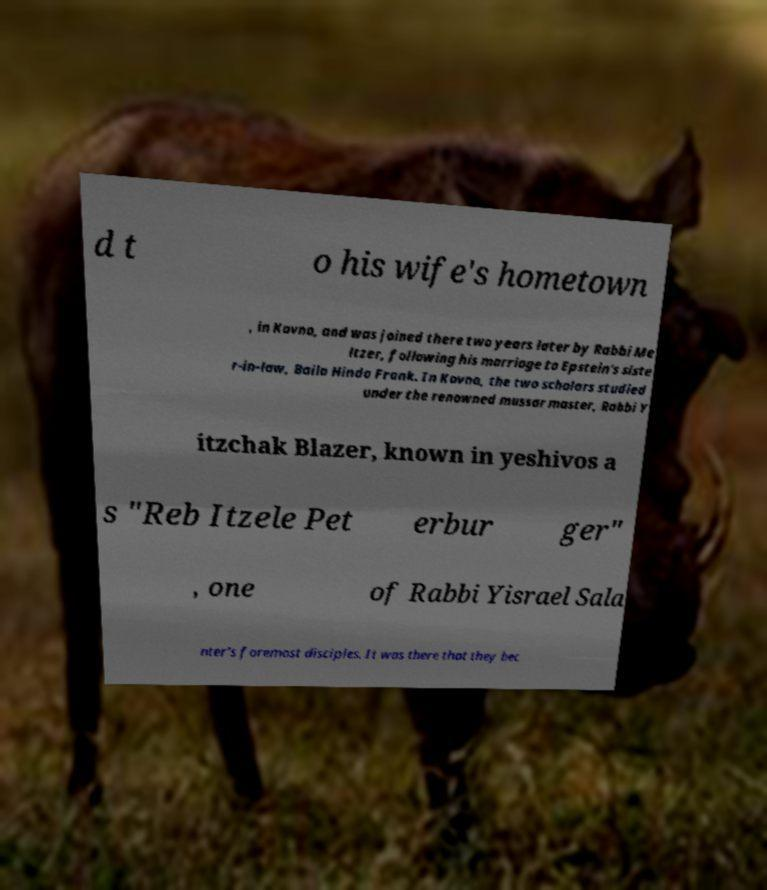Please read and relay the text visible in this image. What does it say? d t o his wife's hometown , in Kovno, and was joined there two years later by Rabbi Me ltzer, following his marriage to Epstein's siste r-in-law, Baila Hinda Frank. In Kovno, the two scholars studied under the renowned mussar master, Rabbi Y itzchak Blazer, known in yeshivos a s "Reb Itzele Pet erbur ger" , one of Rabbi Yisrael Sala nter's foremost disciples. It was there that they bec 